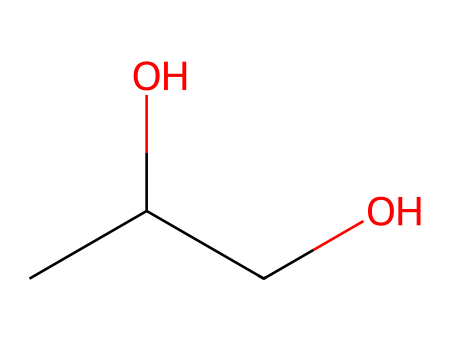What is the molecular formula of propylene glycol? To find the molecular formula, count the carbon (C), hydrogen (H), and oxygen (O) atoms in the provided SMILES representation. There are 3 carbon atoms, 8 hydrogen atoms, and 2 oxygen atoms, giving the formula C3H8O2.
Answer: C3H8O2 How many hydroxyl groups does propylene glycol contain? The structure shows two OH (-OH) groups, which are indicative of hydroxyl functionalities. Each -OH corresponds to the presence of one hydroxyl group.
Answer: 2 What type of chemical bonding is primarily involved in propylene glycol's structure? The structure features covalent bonds, characterized by the sharing of electrons between non-metals. This is evident from the connection between carbon, oxygen, and hydrogen atoms in the SMILES representation.
Answer: covalent Is propylene glycol a polar or nonpolar molecule? The presence of polar hydroxyl groups (OH) suggests a significant degree of polarity in the molecule, as they can form hydrogen bonds with water. The structure has regions that are electronegative, contributing to overall molecular polarity.
Answer: polar What is propylene glycol commonly used for? Analyzing the properties of propylene glycol, it functions as a preservative due to its ability to retain moisture and inhibit microbial growth, making it suitable in food and pharmaceutical applications.
Answer: preservative Which functional groups are present in propylene glycol? Upon examining the structure, there are hydroxyl groups (-OH) identified as the only functional groups. These groups are crucial for its properties as a moisture-retaining agent and a solvent.
Answer: hydroxyl groups 